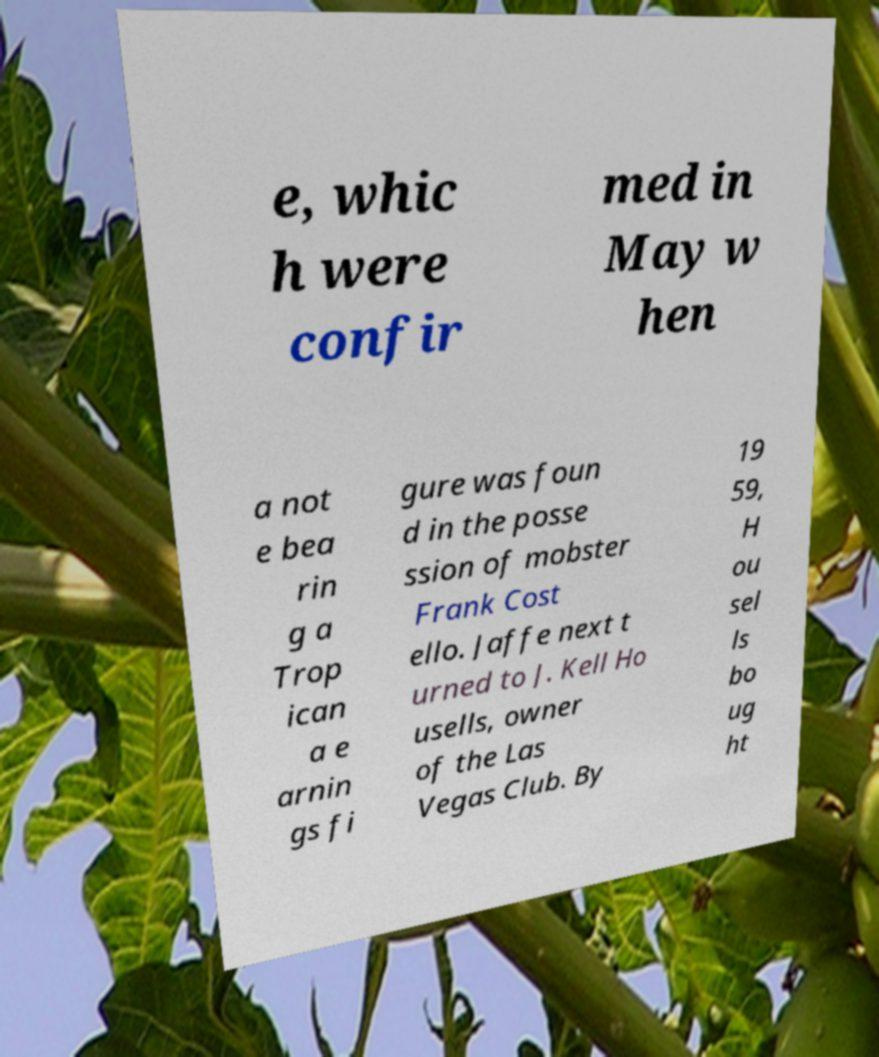Can you read and provide the text displayed in the image?This photo seems to have some interesting text. Can you extract and type it out for me? e, whic h were confir med in May w hen a not e bea rin g a Trop ican a e arnin gs fi gure was foun d in the posse ssion of mobster Frank Cost ello. Jaffe next t urned to J. Kell Ho usells, owner of the Las Vegas Club. By 19 59, H ou sel ls bo ug ht 